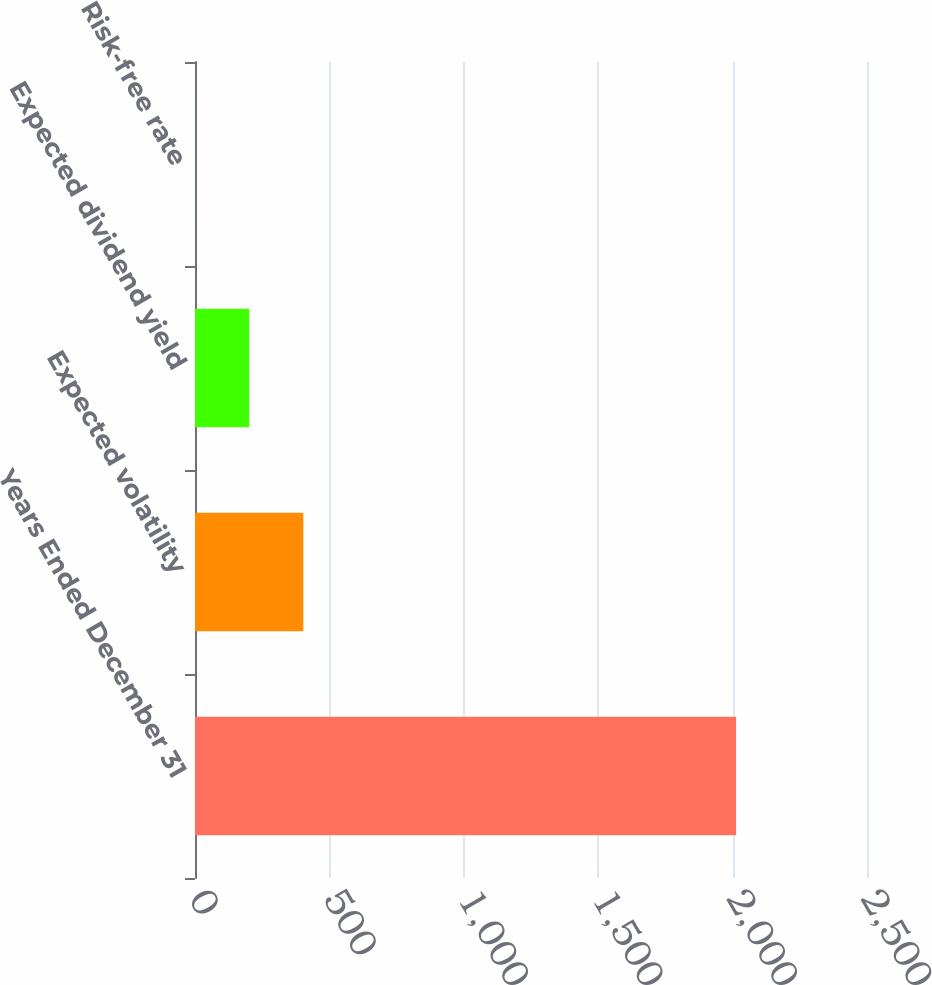Convert chart. <chart><loc_0><loc_0><loc_500><loc_500><bar_chart><fcel>Years Ended December 31<fcel>Expected volatility<fcel>Expected dividend yield<fcel>Risk-free rate<nl><fcel>2013<fcel>402.92<fcel>201.66<fcel>0.4<nl></chart> 